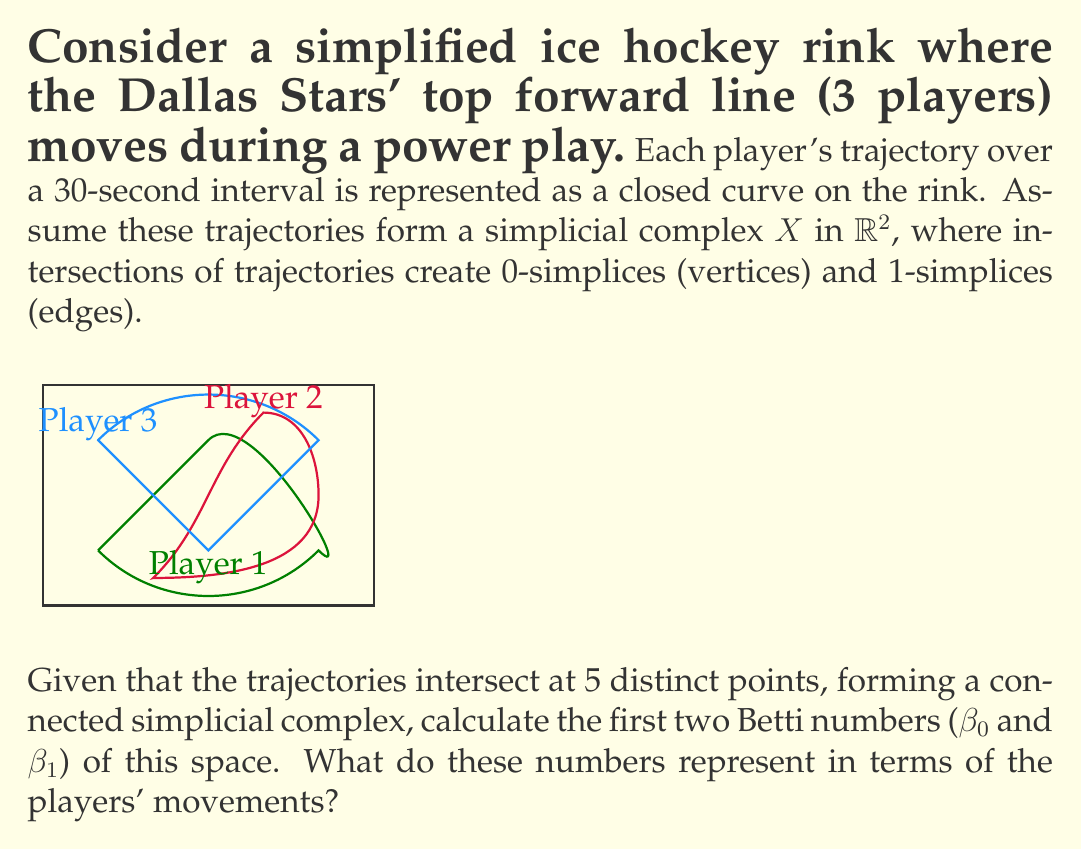Can you solve this math problem? To solve this problem, we'll follow these steps:

1) First, let's recall what Betti numbers represent:
   - $\beta_0$ is the number of connected components
   - $\beta_1$ is the number of 1-dimensional holes (cycles)

2) For our simplicial complex $X$:
   - We have 5 0-simplices (vertices) where trajectories intersect
   - We have 7 1-simplices (edges) formed by trajectory segments between intersections
   - The trajectories form 3 2-simplices (faces)

3) To calculate $\beta_0$:
   - The complex is connected, so there is only one connected component
   - Therefore, $\beta_0 = 1$

4) To calculate $\beta_1$, we'll use the Euler characteristic formula:
   $$\chi(X) = V - E + F = \beta_0 - \beta_1 + \beta_2$$
   Where $V$ is the number of vertices, $E$ is the number of edges, and $F$ is the number of faces.

5) We know:
   - $V = 5$ (intersections)
   - $E = 7$ (trajectory segments between intersections)
   - $F = 3$ (regions enclosed by trajectories)
   - $\beta_0 = 1$ (connected)
   - $\beta_2 = 0$ (no 3D holes in a 2D complex)

6) Substituting into the Euler characteristic formula:
   $$5 - 7 + 3 = 1 - \beta_1 + 0$$
   $$1 = 1 - \beta_1$$
   $$\beta_1 = 0$$

7) Interpretation:
   - $\beta_0 = 1$ means the players' trajectories form a single connected pattern.
   - $\beta_1 = 0$ indicates there are no topological holes in the pattern, meaning the trajectories completely enclose all areas they surround.
Answer: $\beta_0 = 1$, $\beta_1 = 0$. These represent a single connected pattern with no topological holes. 